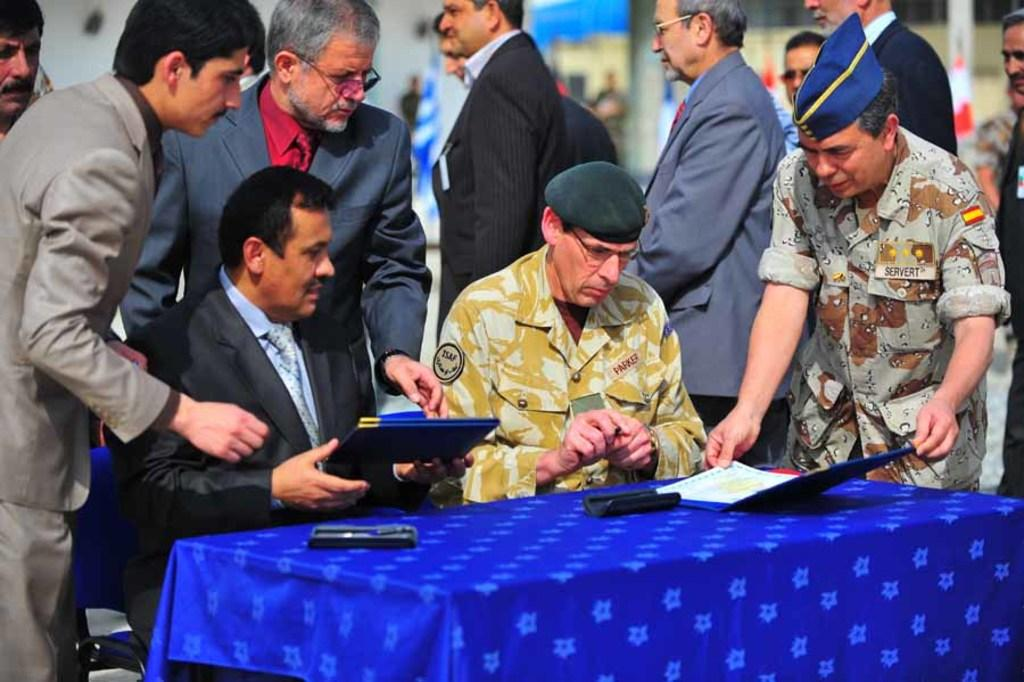How many people are sitting in the image? There are two persons sitting in the image. What are the persons sitting on? The persons are sitting on chairs. Where are the chairs located in relation to the table? The chairs are behind the table. What can be found on the table? There are objects on the table, including a paper. What is happening in the background of the image? There are people walking in the background of the image. Where is the faucet located in the image? There is no faucet present in the image. What type of twig is being used by the persons sitting in the image? There is no twig present in the image; the persons are sitting on chairs behind a table with objects on it. 